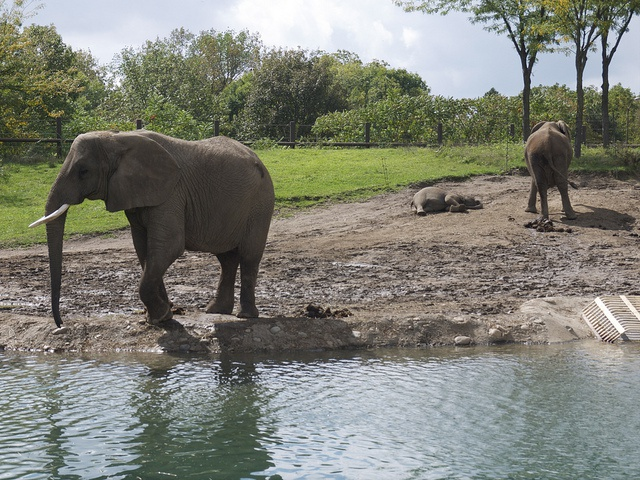Describe the objects in this image and their specific colors. I can see elephant in lavender, black, and gray tones, elephant in lavender, black, and gray tones, and elephant in lavender, black, gray, and darkgray tones in this image. 